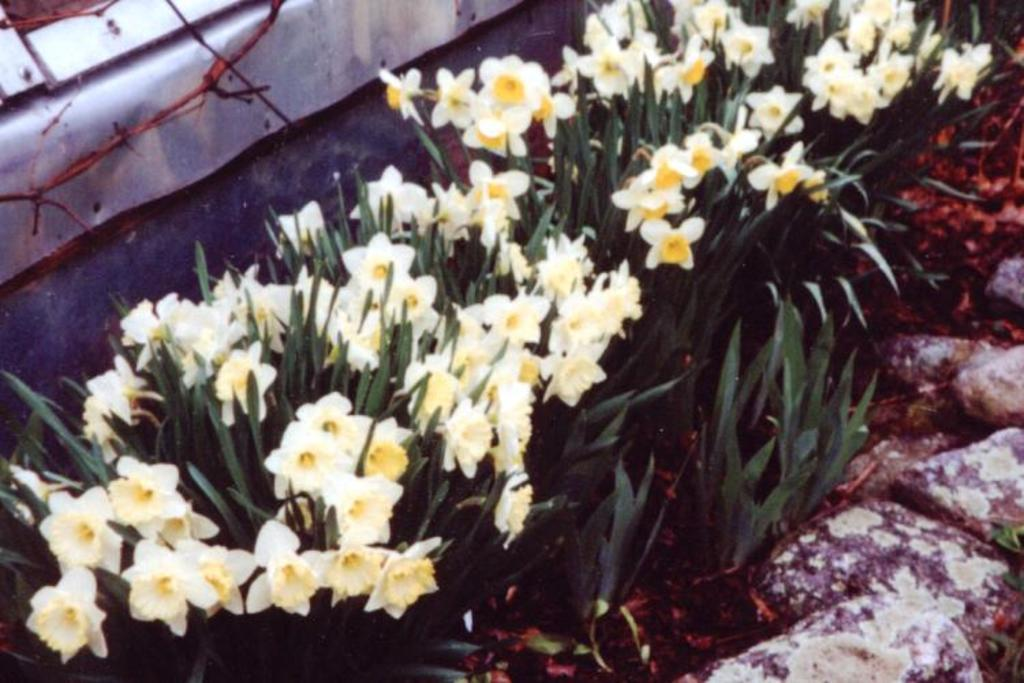What type of flowers are on the plants in the image? The plants in the image have white flowers. What other objects can be seen in the image besides the plants? Rocks and an iron sheet are visible in the image. What type of control panel can be seen on the iron sheet in the image? There is no control panel visible on the iron sheet in the image. 